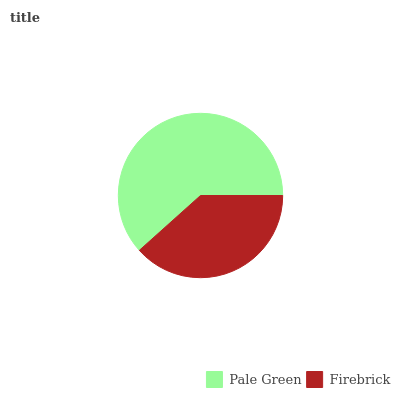Is Firebrick the minimum?
Answer yes or no. Yes. Is Pale Green the maximum?
Answer yes or no. Yes. Is Firebrick the maximum?
Answer yes or no. No. Is Pale Green greater than Firebrick?
Answer yes or no. Yes. Is Firebrick less than Pale Green?
Answer yes or no. Yes. Is Firebrick greater than Pale Green?
Answer yes or no. No. Is Pale Green less than Firebrick?
Answer yes or no. No. Is Pale Green the high median?
Answer yes or no. Yes. Is Firebrick the low median?
Answer yes or no. Yes. Is Firebrick the high median?
Answer yes or no. No. Is Pale Green the low median?
Answer yes or no. No. 